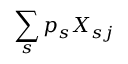<formula> <loc_0><loc_0><loc_500><loc_500>\sum _ { s } p _ { s } X _ { s j }</formula> 